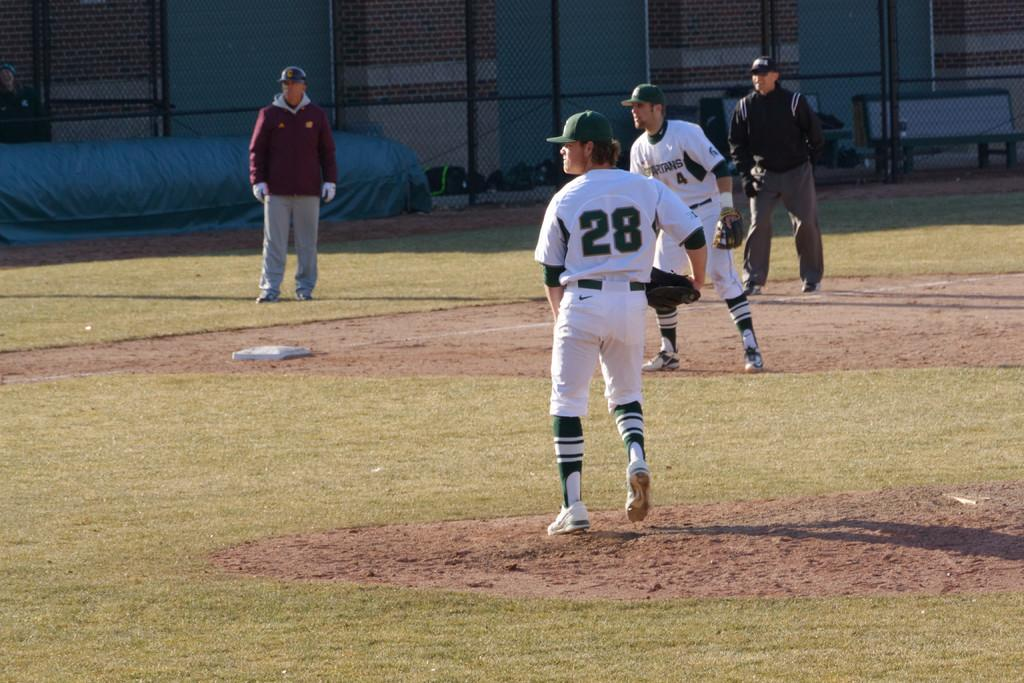<image>
Present a compact description of the photo's key features. Player number 28 is the pitcher in a baseball game taking place on a sunny day. 